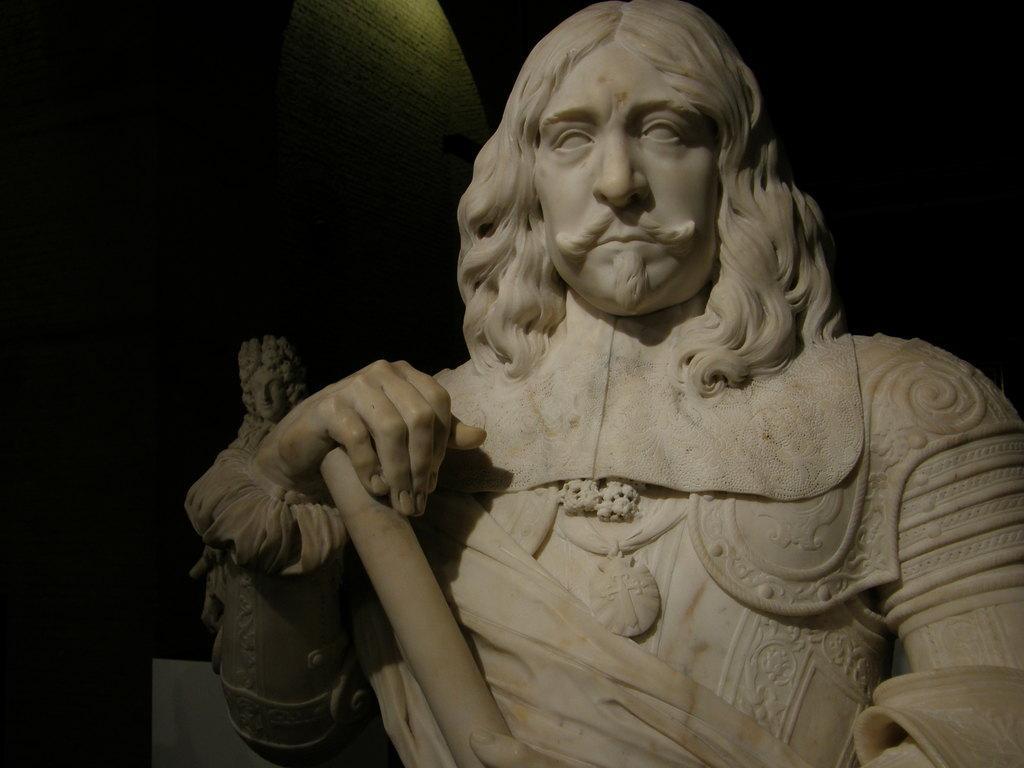Could you give a brief overview of what you see in this image? In this picture there are statues in the center. 